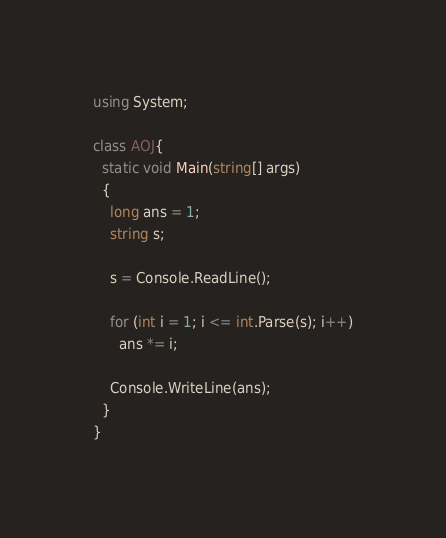Convert code to text. <code><loc_0><loc_0><loc_500><loc_500><_C#_>using System;

class AOJ{
  static void Main(string[] args)
  {
    long ans = 1;
    string s;

    s = Console.ReadLine();

    for (int i = 1; i <= int.Parse(s); i++)
      ans *= i;

    Console.WriteLine(ans);
  }
}</code> 